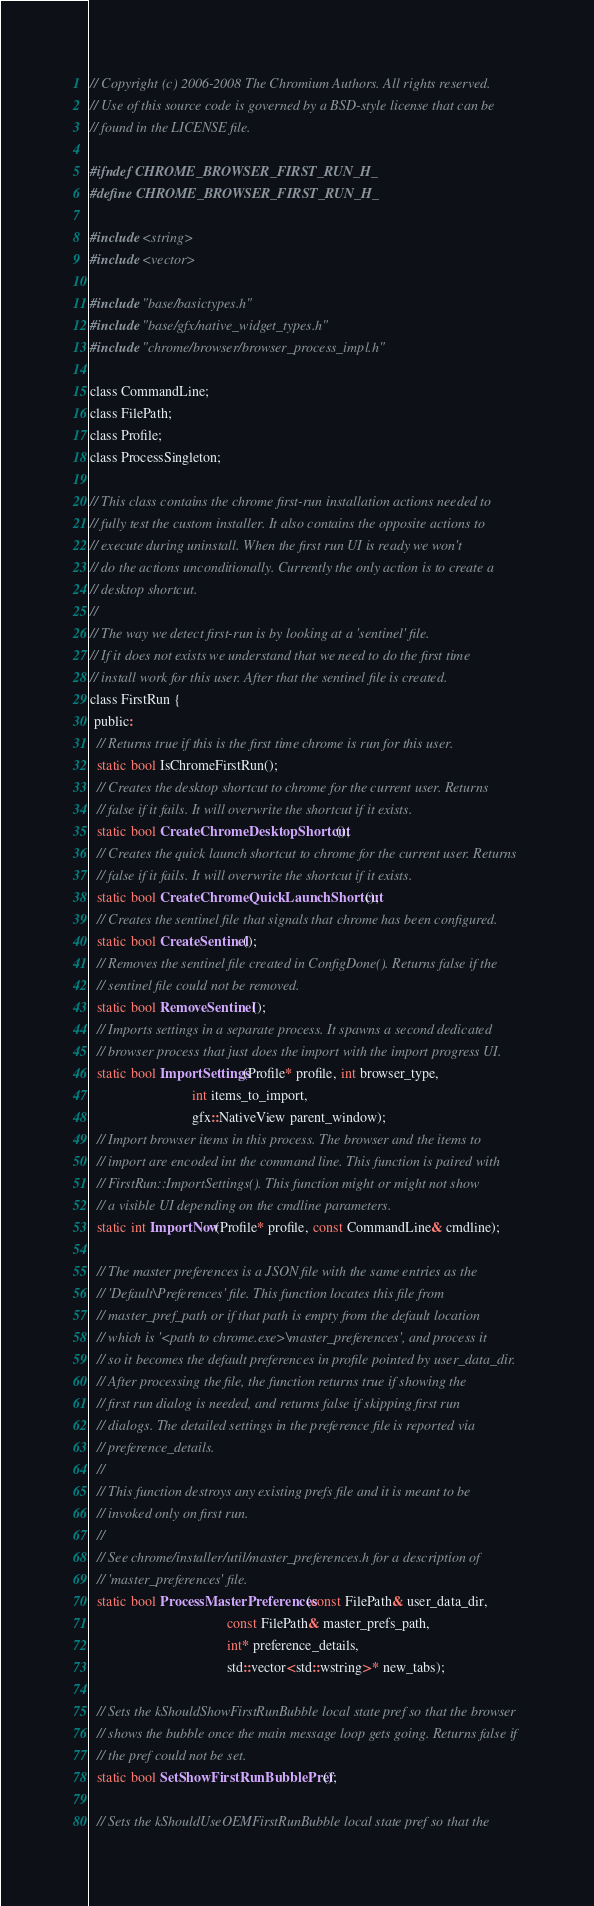<code> <loc_0><loc_0><loc_500><loc_500><_C_>// Copyright (c) 2006-2008 The Chromium Authors. All rights reserved.
// Use of this source code is governed by a BSD-style license that can be
// found in the LICENSE file.

#ifndef CHROME_BROWSER_FIRST_RUN_H_
#define CHROME_BROWSER_FIRST_RUN_H_

#include <string>
#include <vector>

#include "base/basictypes.h"
#include "base/gfx/native_widget_types.h"
#include "chrome/browser/browser_process_impl.h"

class CommandLine;
class FilePath;
class Profile;
class ProcessSingleton;

// This class contains the chrome first-run installation actions needed to
// fully test the custom installer. It also contains the opposite actions to
// execute during uninstall. When the first run UI is ready we won't
// do the actions unconditionally. Currently the only action is to create a
// desktop shortcut.
//
// The way we detect first-run is by looking at a 'sentinel' file.
// If it does not exists we understand that we need to do the first time
// install work for this user. After that the sentinel file is created.
class FirstRun {
 public:
  // Returns true if this is the first time chrome is run for this user.
  static bool IsChromeFirstRun();
  // Creates the desktop shortcut to chrome for the current user. Returns
  // false if it fails. It will overwrite the shortcut if it exists.
  static bool CreateChromeDesktopShortcut();
  // Creates the quick launch shortcut to chrome for the current user. Returns
  // false if it fails. It will overwrite the shortcut if it exists.
  static bool CreateChromeQuickLaunchShortcut();
  // Creates the sentinel file that signals that chrome has been configured.
  static bool CreateSentinel();
  // Removes the sentinel file created in ConfigDone(). Returns false if the
  // sentinel file could not be removed.
  static bool RemoveSentinel();
  // Imports settings in a separate process. It spawns a second dedicated
  // browser process that just does the import with the import progress UI.
  static bool ImportSettings(Profile* profile, int browser_type,
                             int items_to_import,
                             gfx::NativeView parent_window);
  // Import browser items in this process. The browser and the items to
  // import are encoded int the command line. This function is paired with
  // FirstRun::ImportSettings(). This function might or might not show
  // a visible UI depending on the cmdline parameters.
  static int ImportNow(Profile* profile, const CommandLine& cmdline);

  // The master preferences is a JSON file with the same entries as the
  // 'Default\Preferences' file. This function locates this file from
  // master_pref_path or if that path is empty from the default location
  // which is '<path to chrome.exe>\master_preferences', and process it
  // so it becomes the default preferences in profile pointed by user_data_dir.
  // After processing the file, the function returns true if showing the
  // first run dialog is needed, and returns false if skipping first run
  // dialogs. The detailed settings in the preference file is reported via
  // preference_details.
  //
  // This function destroys any existing prefs file and it is meant to be
  // invoked only on first run.
  //
  // See chrome/installer/util/master_preferences.h for a description of
  // 'master_preferences' file.
  static bool ProcessMasterPreferences(const FilePath& user_data_dir,
                                       const FilePath& master_prefs_path,
                                       int* preference_details,
                                       std::vector<std::wstring>* new_tabs);

  // Sets the kShouldShowFirstRunBubble local state pref so that the browser
  // shows the bubble once the main message loop gets going. Returns false if
  // the pref could not be set.
  static bool SetShowFirstRunBubblePref();

  // Sets the kShouldUseOEMFirstRunBubble local state pref so that the</code> 